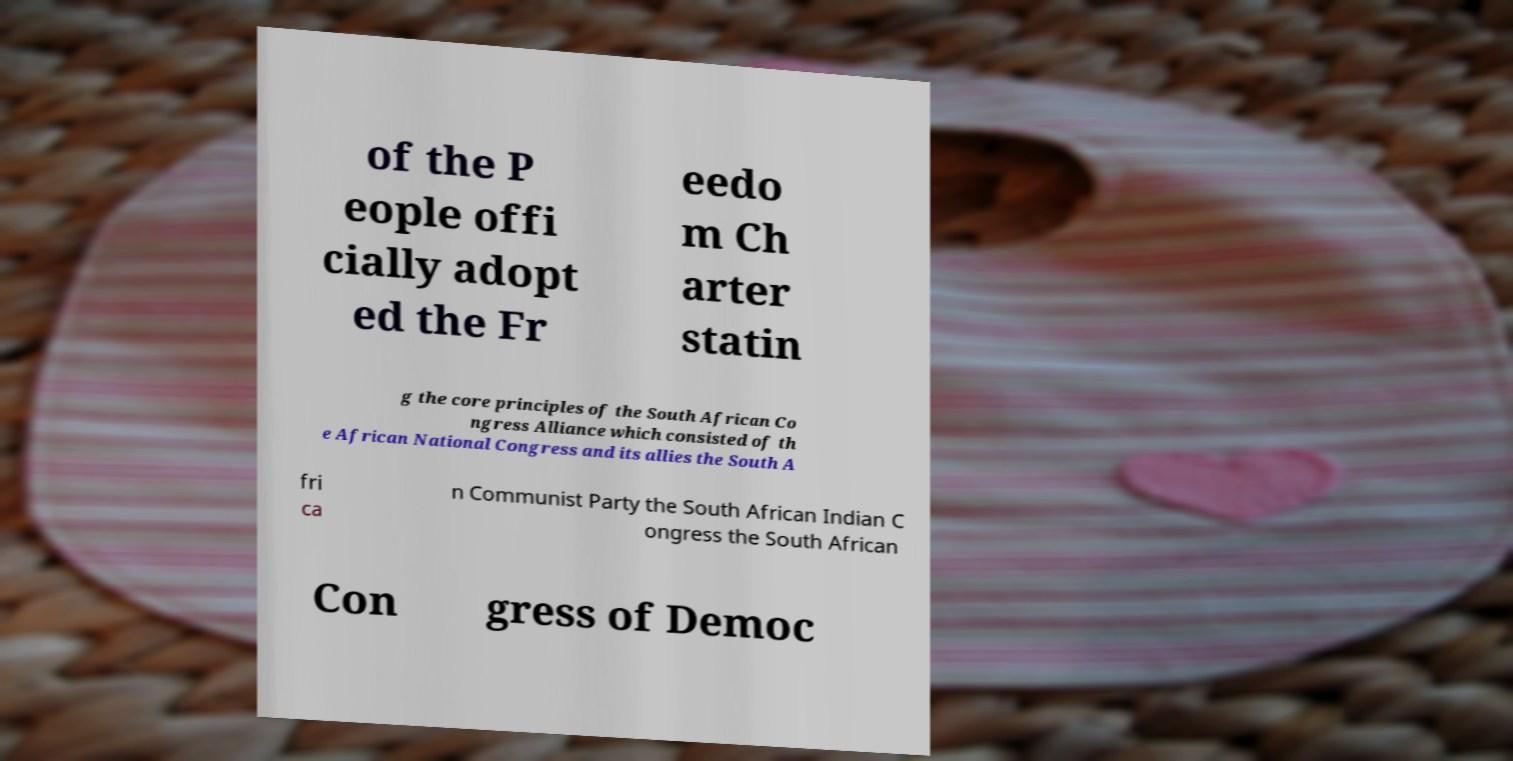Can you read and provide the text displayed in the image?This photo seems to have some interesting text. Can you extract and type it out for me? of the P eople offi cially adopt ed the Fr eedo m Ch arter statin g the core principles of the South African Co ngress Alliance which consisted of th e African National Congress and its allies the South A fri ca n Communist Party the South African Indian C ongress the South African Con gress of Democ 